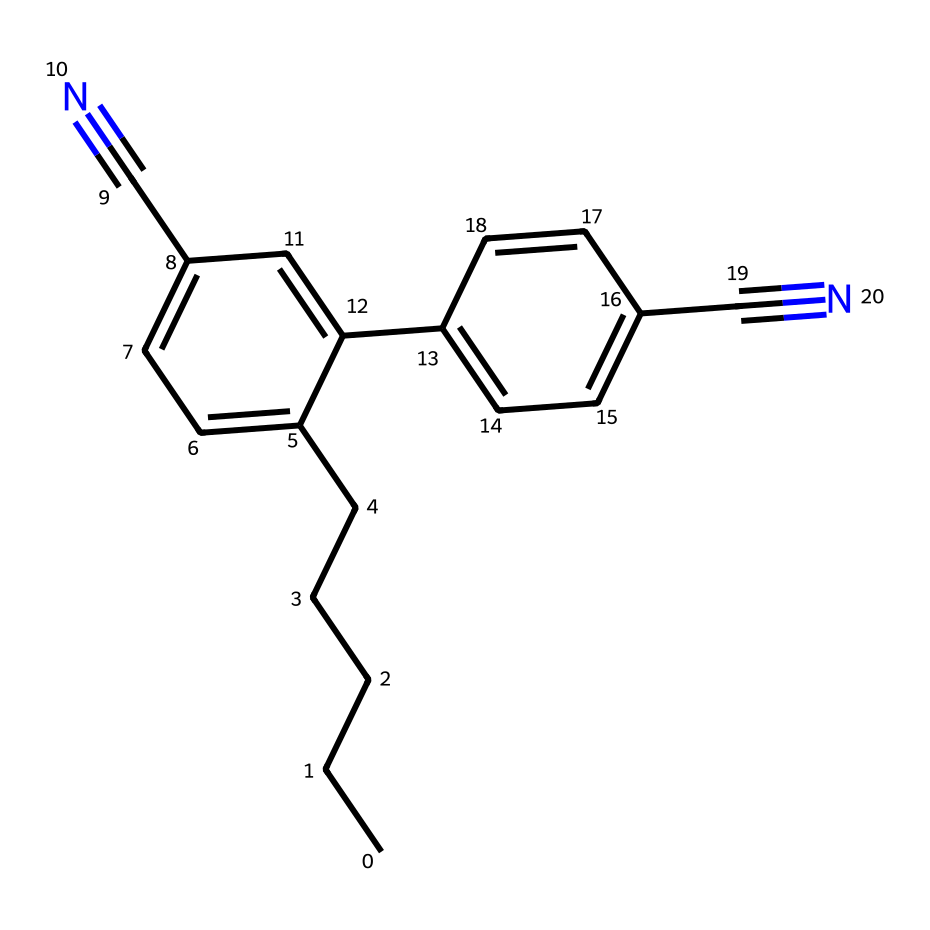What is the total number of carbon atoms in this structure? By examining the SMILES representation, we can count the number of 'C' atoms. In the given structure, there are 16 carbons present.
Answer: 16 How many triple bonds are present in this chemical? The structure features two instances of C#N, which indicates two triple bonds between carbon and nitrogen. Therefore, there are two triple bonds.
Answer: 2 What type of molecular arrangement allows this compound to function in liquid crystal displays? The presence of conjugated double bonds and various rigid ring structures in the compound allows for alignment under electric fields, typical of liquid crystals.
Answer: liquid crystals What is the main functional group in this molecule? The molecule contains cyanide groups indicated by C#N, which are notable functional groups contributing to its chemical properties.
Answer: cyanide Are there any aromatic rings present in the structure? The chemical includes two six-membered carbon rings with alternating double bonds, which conform to the criteria of aromaticity. Therefore, yes, there are aromatic rings.
Answer: yes How many double bonds does the chemical have? By analyzing the structure, we see that there are four double bonds indicated by the '=' symbols in the SMILES, which means the compound has four double bonds.
Answer: 4 